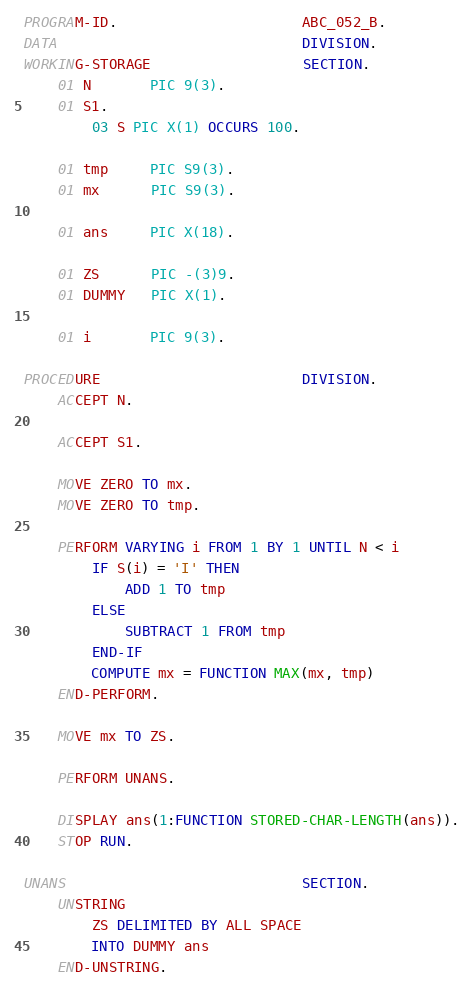Convert code to text. <code><loc_0><loc_0><loc_500><loc_500><_COBOL_>PROGRAM-ID.                      ABC_052_B.
DATA                             DIVISION.
WORKING-STORAGE                  SECTION.
    01 N       PIC 9(3).
    01 S1.
        03 S PIC X(1) OCCURS 100.

    01 tmp     PIC S9(3).
    01 mx      PIC S9(3).

    01 ans     PIC X(18).

    01 ZS      PIC -(3)9.
    01 DUMMY   PIC X(1).

    01 i       PIC 9(3).

PROCEDURE                        DIVISION.
    ACCEPT N.

    ACCEPT S1.

    MOVE ZERO TO mx.
    MOVE ZERO TO tmp.

    PERFORM VARYING i FROM 1 BY 1 UNTIL N < i
        IF S(i) = 'I' THEN
            ADD 1 TO tmp
        ELSE
            SUBTRACT 1 FROM tmp
        END-IF
        COMPUTE mx = FUNCTION MAX(mx, tmp)
    END-PERFORM.

    MOVE mx TO ZS.

    PERFORM UNANS.

    DISPLAY ans(1:FUNCTION STORED-CHAR-LENGTH(ans)).
    STOP RUN.

UNANS                            SECTION.
    UNSTRING
        ZS DELIMITED BY ALL SPACE
        INTO DUMMY ans
    END-UNSTRING.
</code> 